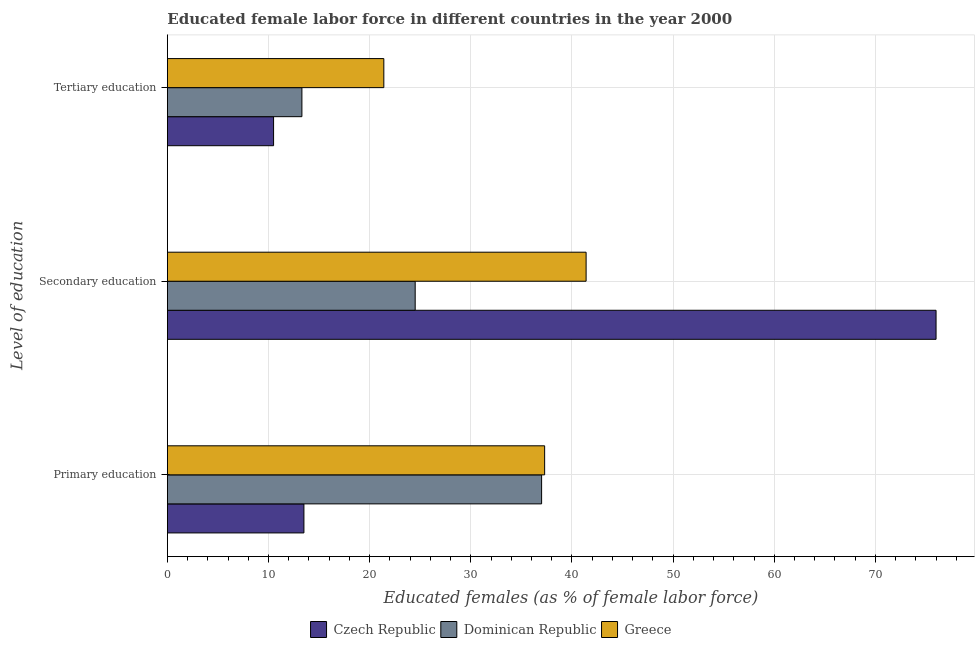Are the number of bars per tick equal to the number of legend labels?
Make the answer very short. Yes. Are the number of bars on each tick of the Y-axis equal?
Provide a succinct answer. Yes. How many bars are there on the 3rd tick from the top?
Your answer should be very brief. 3. What is the label of the 1st group of bars from the top?
Provide a short and direct response. Tertiary education. Across all countries, what is the minimum percentage of female labor force who received secondary education?
Offer a terse response. 24.5. In which country was the percentage of female labor force who received primary education maximum?
Provide a succinct answer. Greece. In which country was the percentage of female labor force who received tertiary education minimum?
Your answer should be compact. Czech Republic. What is the total percentage of female labor force who received secondary education in the graph?
Your answer should be compact. 141.9. What is the difference between the percentage of female labor force who received primary education in Greece and that in Dominican Republic?
Offer a terse response. 0.3. What is the difference between the percentage of female labor force who received tertiary education in Czech Republic and the percentage of female labor force who received primary education in Dominican Republic?
Provide a succinct answer. -26.5. What is the average percentage of female labor force who received primary education per country?
Provide a short and direct response. 29.27. What is the difference between the percentage of female labor force who received tertiary education and percentage of female labor force who received primary education in Czech Republic?
Make the answer very short. -3. In how many countries, is the percentage of female labor force who received primary education greater than 54 %?
Provide a short and direct response. 0. What is the ratio of the percentage of female labor force who received primary education in Czech Republic to that in Greece?
Make the answer very short. 0.36. Is the percentage of female labor force who received primary education in Dominican Republic less than that in Czech Republic?
Your response must be concise. No. Is the difference between the percentage of female labor force who received secondary education in Czech Republic and Greece greater than the difference between the percentage of female labor force who received tertiary education in Czech Republic and Greece?
Ensure brevity in your answer.  Yes. What is the difference between the highest and the second highest percentage of female labor force who received primary education?
Your answer should be compact. 0.3. What is the difference between the highest and the lowest percentage of female labor force who received secondary education?
Your answer should be very brief. 51.5. In how many countries, is the percentage of female labor force who received secondary education greater than the average percentage of female labor force who received secondary education taken over all countries?
Ensure brevity in your answer.  1. Is the sum of the percentage of female labor force who received primary education in Czech Republic and Greece greater than the maximum percentage of female labor force who received tertiary education across all countries?
Provide a short and direct response. Yes. What does the 1st bar from the top in Secondary education represents?
Your response must be concise. Greece. What does the 2nd bar from the bottom in Tertiary education represents?
Give a very brief answer. Dominican Republic. How many bars are there?
Offer a terse response. 9. Are all the bars in the graph horizontal?
Keep it short and to the point. Yes. Does the graph contain any zero values?
Offer a very short reply. No. Where does the legend appear in the graph?
Ensure brevity in your answer.  Bottom center. How many legend labels are there?
Give a very brief answer. 3. What is the title of the graph?
Provide a succinct answer. Educated female labor force in different countries in the year 2000. Does "Guam" appear as one of the legend labels in the graph?
Provide a short and direct response. No. What is the label or title of the X-axis?
Offer a very short reply. Educated females (as % of female labor force). What is the label or title of the Y-axis?
Your answer should be compact. Level of education. What is the Educated females (as % of female labor force) of Greece in Primary education?
Provide a short and direct response. 37.3. What is the Educated females (as % of female labor force) of Greece in Secondary education?
Provide a succinct answer. 41.4. What is the Educated females (as % of female labor force) of Dominican Republic in Tertiary education?
Your answer should be compact. 13.3. What is the Educated females (as % of female labor force) of Greece in Tertiary education?
Your response must be concise. 21.4. Across all Level of education, what is the maximum Educated females (as % of female labor force) in Czech Republic?
Give a very brief answer. 76. Across all Level of education, what is the maximum Educated females (as % of female labor force) in Dominican Republic?
Your response must be concise. 37. Across all Level of education, what is the maximum Educated females (as % of female labor force) of Greece?
Offer a very short reply. 41.4. Across all Level of education, what is the minimum Educated females (as % of female labor force) of Dominican Republic?
Your response must be concise. 13.3. Across all Level of education, what is the minimum Educated females (as % of female labor force) of Greece?
Provide a succinct answer. 21.4. What is the total Educated females (as % of female labor force) in Czech Republic in the graph?
Your response must be concise. 100. What is the total Educated females (as % of female labor force) of Dominican Republic in the graph?
Offer a very short reply. 74.8. What is the total Educated females (as % of female labor force) in Greece in the graph?
Your response must be concise. 100.1. What is the difference between the Educated females (as % of female labor force) in Czech Republic in Primary education and that in Secondary education?
Offer a very short reply. -62.5. What is the difference between the Educated females (as % of female labor force) of Dominican Republic in Primary education and that in Tertiary education?
Your response must be concise. 23.7. What is the difference between the Educated females (as % of female labor force) of Czech Republic in Secondary education and that in Tertiary education?
Your answer should be compact. 65.5. What is the difference between the Educated females (as % of female labor force) of Dominican Republic in Secondary education and that in Tertiary education?
Keep it short and to the point. 11.2. What is the difference between the Educated females (as % of female labor force) in Greece in Secondary education and that in Tertiary education?
Keep it short and to the point. 20. What is the difference between the Educated females (as % of female labor force) of Czech Republic in Primary education and the Educated females (as % of female labor force) of Dominican Republic in Secondary education?
Your answer should be compact. -11. What is the difference between the Educated females (as % of female labor force) of Czech Republic in Primary education and the Educated females (as % of female labor force) of Greece in Secondary education?
Offer a very short reply. -27.9. What is the difference between the Educated females (as % of female labor force) in Dominican Republic in Primary education and the Educated females (as % of female labor force) in Greece in Secondary education?
Give a very brief answer. -4.4. What is the difference between the Educated females (as % of female labor force) of Czech Republic in Primary education and the Educated females (as % of female labor force) of Greece in Tertiary education?
Your response must be concise. -7.9. What is the difference between the Educated females (as % of female labor force) in Czech Republic in Secondary education and the Educated females (as % of female labor force) in Dominican Republic in Tertiary education?
Offer a very short reply. 62.7. What is the difference between the Educated females (as % of female labor force) in Czech Republic in Secondary education and the Educated females (as % of female labor force) in Greece in Tertiary education?
Provide a succinct answer. 54.6. What is the average Educated females (as % of female labor force) in Czech Republic per Level of education?
Your response must be concise. 33.33. What is the average Educated females (as % of female labor force) of Dominican Republic per Level of education?
Give a very brief answer. 24.93. What is the average Educated females (as % of female labor force) of Greece per Level of education?
Make the answer very short. 33.37. What is the difference between the Educated females (as % of female labor force) in Czech Republic and Educated females (as % of female labor force) in Dominican Republic in Primary education?
Your response must be concise. -23.5. What is the difference between the Educated females (as % of female labor force) in Czech Republic and Educated females (as % of female labor force) in Greece in Primary education?
Provide a succinct answer. -23.8. What is the difference between the Educated females (as % of female labor force) in Dominican Republic and Educated females (as % of female labor force) in Greece in Primary education?
Your response must be concise. -0.3. What is the difference between the Educated females (as % of female labor force) of Czech Republic and Educated females (as % of female labor force) of Dominican Republic in Secondary education?
Make the answer very short. 51.5. What is the difference between the Educated females (as % of female labor force) of Czech Republic and Educated females (as % of female labor force) of Greece in Secondary education?
Offer a terse response. 34.6. What is the difference between the Educated females (as % of female labor force) in Dominican Republic and Educated females (as % of female labor force) in Greece in Secondary education?
Ensure brevity in your answer.  -16.9. What is the difference between the Educated females (as % of female labor force) in Czech Republic and Educated females (as % of female labor force) in Dominican Republic in Tertiary education?
Your answer should be very brief. -2.8. What is the difference between the Educated females (as % of female labor force) of Czech Republic and Educated females (as % of female labor force) of Greece in Tertiary education?
Make the answer very short. -10.9. What is the ratio of the Educated females (as % of female labor force) of Czech Republic in Primary education to that in Secondary education?
Offer a terse response. 0.18. What is the ratio of the Educated females (as % of female labor force) of Dominican Republic in Primary education to that in Secondary education?
Your answer should be compact. 1.51. What is the ratio of the Educated females (as % of female labor force) in Greece in Primary education to that in Secondary education?
Provide a succinct answer. 0.9. What is the ratio of the Educated females (as % of female labor force) of Dominican Republic in Primary education to that in Tertiary education?
Your response must be concise. 2.78. What is the ratio of the Educated females (as % of female labor force) of Greece in Primary education to that in Tertiary education?
Your answer should be very brief. 1.74. What is the ratio of the Educated females (as % of female labor force) of Czech Republic in Secondary education to that in Tertiary education?
Make the answer very short. 7.24. What is the ratio of the Educated females (as % of female labor force) in Dominican Republic in Secondary education to that in Tertiary education?
Offer a terse response. 1.84. What is the ratio of the Educated females (as % of female labor force) of Greece in Secondary education to that in Tertiary education?
Offer a very short reply. 1.93. What is the difference between the highest and the second highest Educated females (as % of female labor force) of Czech Republic?
Provide a short and direct response. 62.5. What is the difference between the highest and the second highest Educated females (as % of female labor force) of Dominican Republic?
Your answer should be very brief. 12.5. What is the difference between the highest and the lowest Educated females (as % of female labor force) in Czech Republic?
Provide a succinct answer. 65.5. What is the difference between the highest and the lowest Educated females (as % of female labor force) in Dominican Republic?
Offer a terse response. 23.7. 